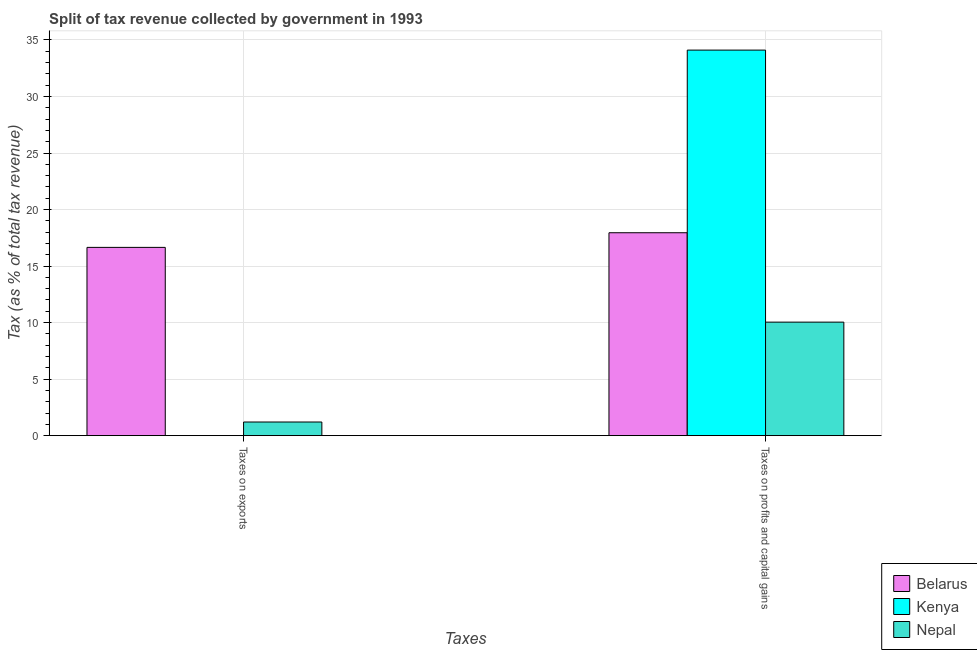How many different coloured bars are there?
Ensure brevity in your answer.  3. Are the number of bars on each tick of the X-axis equal?
Offer a terse response. Yes. What is the label of the 2nd group of bars from the left?
Your response must be concise. Taxes on profits and capital gains. What is the percentage of revenue obtained from taxes on exports in Nepal?
Make the answer very short. 1.21. Across all countries, what is the maximum percentage of revenue obtained from taxes on profits and capital gains?
Make the answer very short. 34.11. Across all countries, what is the minimum percentage of revenue obtained from taxes on exports?
Offer a very short reply. 0. In which country was the percentage of revenue obtained from taxes on exports maximum?
Provide a short and direct response. Belarus. In which country was the percentage of revenue obtained from taxes on profits and capital gains minimum?
Give a very brief answer. Nepal. What is the total percentage of revenue obtained from taxes on exports in the graph?
Ensure brevity in your answer.  17.86. What is the difference between the percentage of revenue obtained from taxes on profits and capital gains in Nepal and that in Kenya?
Provide a short and direct response. -24.06. What is the difference between the percentage of revenue obtained from taxes on exports in Kenya and the percentage of revenue obtained from taxes on profits and capital gains in Nepal?
Your answer should be very brief. -10.04. What is the average percentage of revenue obtained from taxes on exports per country?
Your response must be concise. 5.95. What is the difference between the percentage of revenue obtained from taxes on profits and capital gains and percentage of revenue obtained from taxes on exports in Belarus?
Give a very brief answer. 1.3. What is the ratio of the percentage of revenue obtained from taxes on profits and capital gains in Nepal to that in Belarus?
Your answer should be very brief. 0.56. Is the percentage of revenue obtained from taxes on profits and capital gains in Belarus less than that in Kenya?
Your response must be concise. Yes. In how many countries, is the percentage of revenue obtained from taxes on exports greater than the average percentage of revenue obtained from taxes on exports taken over all countries?
Offer a very short reply. 1. What does the 2nd bar from the left in Taxes on profits and capital gains represents?
Ensure brevity in your answer.  Kenya. What does the 2nd bar from the right in Taxes on profits and capital gains represents?
Your answer should be compact. Kenya. How many countries are there in the graph?
Give a very brief answer. 3. Are the values on the major ticks of Y-axis written in scientific E-notation?
Your response must be concise. No. Does the graph contain any zero values?
Your answer should be compact. No. Does the graph contain grids?
Keep it short and to the point. Yes. Where does the legend appear in the graph?
Give a very brief answer. Bottom right. How many legend labels are there?
Your answer should be compact. 3. How are the legend labels stacked?
Keep it short and to the point. Vertical. What is the title of the graph?
Provide a succinct answer. Split of tax revenue collected by government in 1993. What is the label or title of the X-axis?
Your answer should be very brief. Taxes. What is the label or title of the Y-axis?
Provide a succinct answer. Tax (as % of total tax revenue). What is the Tax (as % of total tax revenue) in Belarus in Taxes on exports?
Offer a very short reply. 16.65. What is the Tax (as % of total tax revenue) in Kenya in Taxes on exports?
Keep it short and to the point. 0. What is the Tax (as % of total tax revenue) of Nepal in Taxes on exports?
Ensure brevity in your answer.  1.21. What is the Tax (as % of total tax revenue) of Belarus in Taxes on profits and capital gains?
Your response must be concise. 17.95. What is the Tax (as % of total tax revenue) in Kenya in Taxes on profits and capital gains?
Your answer should be very brief. 34.11. What is the Tax (as % of total tax revenue) of Nepal in Taxes on profits and capital gains?
Provide a short and direct response. 10.04. Across all Taxes, what is the maximum Tax (as % of total tax revenue) in Belarus?
Offer a terse response. 17.95. Across all Taxes, what is the maximum Tax (as % of total tax revenue) in Kenya?
Your answer should be compact. 34.11. Across all Taxes, what is the maximum Tax (as % of total tax revenue) in Nepal?
Make the answer very short. 10.04. Across all Taxes, what is the minimum Tax (as % of total tax revenue) of Belarus?
Ensure brevity in your answer.  16.65. Across all Taxes, what is the minimum Tax (as % of total tax revenue) of Kenya?
Offer a terse response. 0. Across all Taxes, what is the minimum Tax (as % of total tax revenue) of Nepal?
Your response must be concise. 1.21. What is the total Tax (as % of total tax revenue) in Belarus in the graph?
Provide a short and direct response. 34.6. What is the total Tax (as % of total tax revenue) in Kenya in the graph?
Keep it short and to the point. 34.11. What is the total Tax (as % of total tax revenue) of Nepal in the graph?
Give a very brief answer. 11.25. What is the difference between the Tax (as % of total tax revenue) of Belarus in Taxes on exports and that in Taxes on profits and capital gains?
Give a very brief answer. -1.3. What is the difference between the Tax (as % of total tax revenue) of Kenya in Taxes on exports and that in Taxes on profits and capital gains?
Provide a short and direct response. -34.1. What is the difference between the Tax (as % of total tax revenue) of Nepal in Taxes on exports and that in Taxes on profits and capital gains?
Offer a terse response. -8.84. What is the difference between the Tax (as % of total tax revenue) of Belarus in Taxes on exports and the Tax (as % of total tax revenue) of Kenya in Taxes on profits and capital gains?
Provide a succinct answer. -17.45. What is the difference between the Tax (as % of total tax revenue) in Belarus in Taxes on exports and the Tax (as % of total tax revenue) in Nepal in Taxes on profits and capital gains?
Keep it short and to the point. 6.61. What is the difference between the Tax (as % of total tax revenue) of Kenya in Taxes on exports and the Tax (as % of total tax revenue) of Nepal in Taxes on profits and capital gains?
Provide a short and direct response. -10.04. What is the average Tax (as % of total tax revenue) of Belarus per Taxes?
Your answer should be compact. 17.3. What is the average Tax (as % of total tax revenue) in Kenya per Taxes?
Provide a succinct answer. 17.05. What is the average Tax (as % of total tax revenue) of Nepal per Taxes?
Keep it short and to the point. 5.62. What is the difference between the Tax (as % of total tax revenue) of Belarus and Tax (as % of total tax revenue) of Kenya in Taxes on exports?
Offer a terse response. 16.65. What is the difference between the Tax (as % of total tax revenue) of Belarus and Tax (as % of total tax revenue) of Nepal in Taxes on exports?
Give a very brief answer. 15.45. What is the difference between the Tax (as % of total tax revenue) of Kenya and Tax (as % of total tax revenue) of Nepal in Taxes on exports?
Your answer should be compact. -1.2. What is the difference between the Tax (as % of total tax revenue) of Belarus and Tax (as % of total tax revenue) of Kenya in Taxes on profits and capital gains?
Your response must be concise. -16.16. What is the difference between the Tax (as % of total tax revenue) in Belarus and Tax (as % of total tax revenue) in Nepal in Taxes on profits and capital gains?
Ensure brevity in your answer.  7.91. What is the difference between the Tax (as % of total tax revenue) of Kenya and Tax (as % of total tax revenue) of Nepal in Taxes on profits and capital gains?
Provide a short and direct response. 24.06. What is the ratio of the Tax (as % of total tax revenue) of Belarus in Taxes on exports to that in Taxes on profits and capital gains?
Ensure brevity in your answer.  0.93. What is the ratio of the Tax (as % of total tax revenue) of Kenya in Taxes on exports to that in Taxes on profits and capital gains?
Give a very brief answer. 0. What is the ratio of the Tax (as % of total tax revenue) in Nepal in Taxes on exports to that in Taxes on profits and capital gains?
Provide a short and direct response. 0.12. What is the difference between the highest and the second highest Tax (as % of total tax revenue) of Belarus?
Offer a very short reply. 1.3. What is the difference between the highest and the second highest Tax (as % of total tax revenue) of Kenya?
Give a very brief answer. 34.1. What is the difference between the highest and the second highest Tax (as % of total tax revenue) of Nepal?
Your answer should be compact. 8.84. What is the difference between the highest and the lowest Tax (as % of total tax revenue) of Belarus?
Make the answer very short. 1.3. What is the difference between the highest and the lowest Tax (as % of total tax revenue) of Kenya?
Offer a very short reply. 34.1. What is the difference between the highest and the lowest Tax (as % of total tax revenue) in Nepal?
Offer a very short reply. 8.84. 